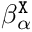Convert formula to latex. <formula><loc_0><loc_0><loc_500><loc_500>\beta _ { \alpha } ^ { \tt X }</formula> 